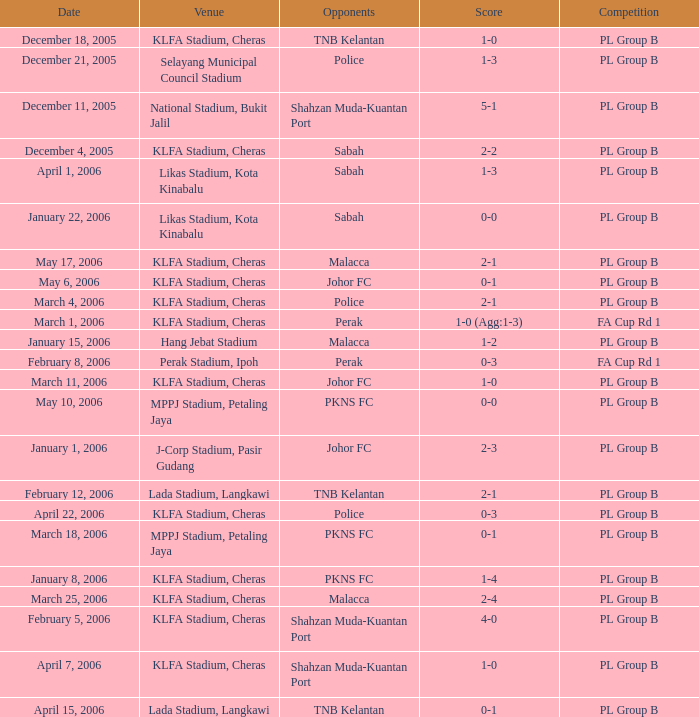Which date includes a competitive event for pl group b against the police, held at the selayang municipal council stadium? December 21, 2005. 